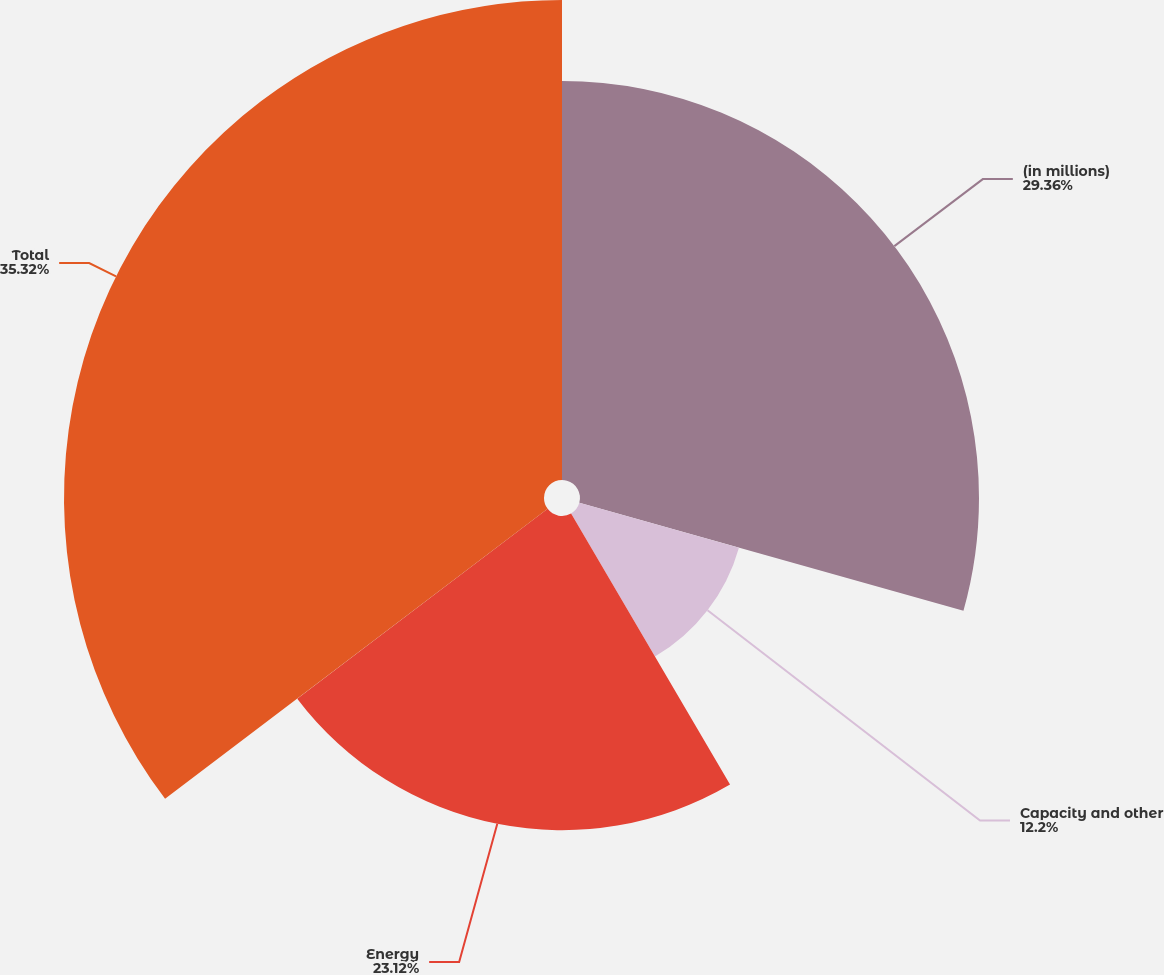<chart> <loc_0><loc_0><loc_500><loc_500><pie_chart><fcel>(in millions)<fcel>Capacity and other<fcel>Energy<fcel>Total<nl><fcel>29.36%<fcel>12.2%<fcel>23.12%<fcel>35.32%<nl></chart> 